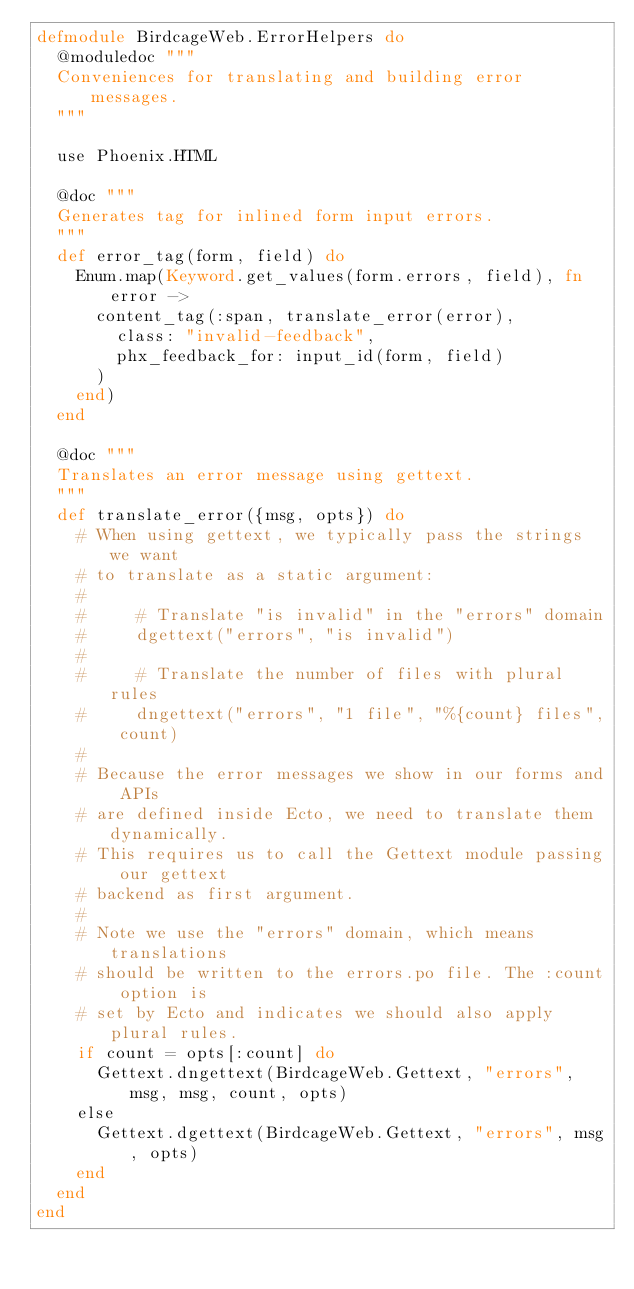<code> <loc_0><loc_0><loc_500><loc_500><_Elixir_>defmodule BirdcageWeb.ErrorHelpers do
  @moduledoc """
  Conveniences for translating and building error messages.
  """

  use Phoenix.HTML

  @doc """
  Generates tag for inlined form input errors.
  """
  def error_tag(form, field) do
    Enum.map(Keyword.get_values(form.errors, field), fn error ->
      content_tag(:span, translate_error(error),
        class: "invalid-feedback",
        phx_feedback_for: input_id(form, field)
      )
    end)
  end

  @doc """
  Translates an error message using gettext.
  """
  def translate_error({msg, opts}) do
    # When using gettext, we typically pass the strings we want
    # to translate as a static argument:
    #
    #     # Translate "is invalid" in the "errors" domain
    #     dgettext("errors", "is invalid")
    #
    #     # Translate the number of files with plural rules
    #     dngettext("errors", "1 file", "%{count} files", count)
    #
    # Because the error messages we show in our forms and APIs
    # are defined inside Ecto, we need to translate them dynamically.
    # This requires us to call the Gettext module passing our gettext
    # backend as first argument.
    #
    # Note we use the "errors" domain, which means translations
    # should be written to the errors.po file. The :count option is
    # set by Ecto and indicates we should also apply plural rules.
    if count = opts[:count] do
      Gettext.dngettext(BirdcageWeb.Gettext, "errors", msg, msg, count, opts)
    else
      Gettext.dgettext(BirdcageWeb.Gettext, "errors", msg, opts)
    end
  end
end
</code> 